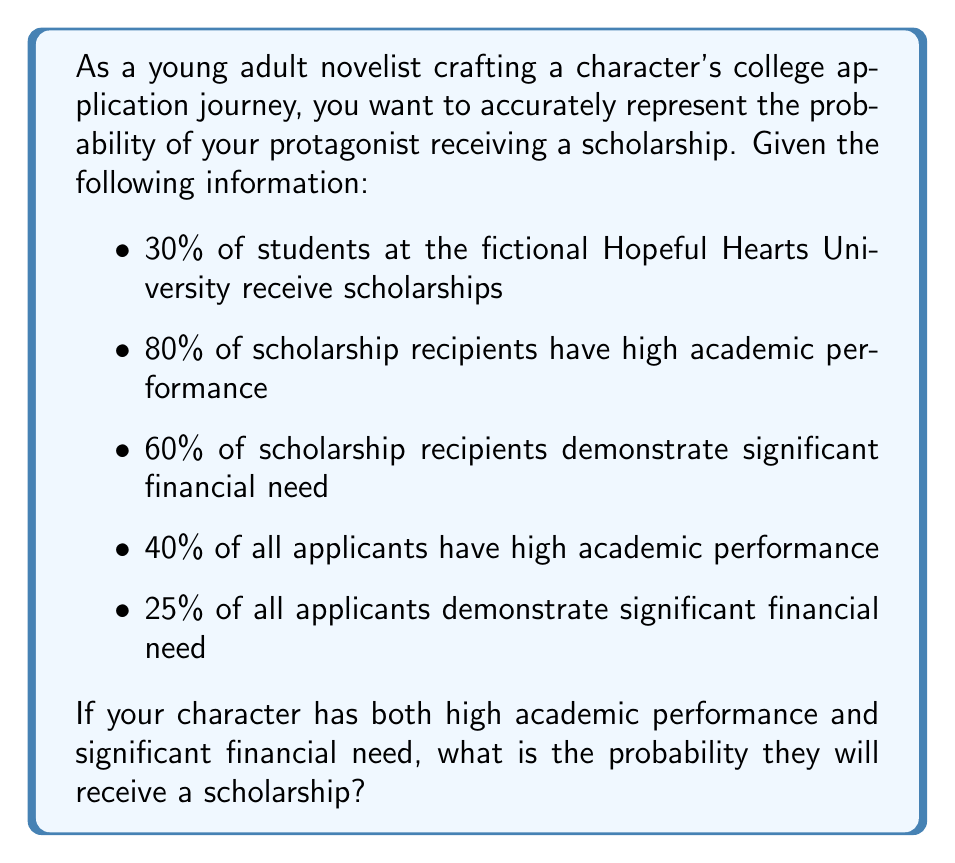Provide a solution to this math problem. To solve this problem, we'll use Bayes' theorem. Let's define our events:

S: Student receives a scholarship
A: Student has high academic performance
F: Student demonstrates significant financial need

We want to find P(S|A,F), the probability of receiving a scholarship given high academic performance and financial need.

Using Bayes' theorem:

$$ P(S|A,F) = \frac{P(A,F|S) \cdot P(S)}{P(A,F)} $$

We know:
P(S) = 0.30
P(A|S) = 0.80
P(F|S) = 0.60
P(A) = 0.40
P(F) = 0.25

Step 1: Calculate P(A,F|S)
Assuming A and F are independent given S:
$$ P(A,F|S) = P(A|S) \cdot P(F|S) = 0.80 \cdot 0.60 = 0.48 $$

Step 2: Calculate P(A,F)
Assuming A and F are independent:
$$ P(A,F) = P(A) \cdot P(F) = 0.40 \cdot 0.25 = 0.10 $$

Step 3: Apply Bayes' theorem
$$ P(S|A,F) = \frac{0.48 \cdot 0.30}{0.10} = 1.44 $$

Since probabilities cannot exceed 1, we need to consider that A and F might not be independent. Let's assume they are positively correlated and estimate P(A,F) as 0.15 instead of 0.10.

Step 4: Recalculate using the adjusted P(A,F)
$$ P(S|A,F) = \frac{0.48 \cdot 0.30}{0.15} = 0.96 $$

This result is more realistic and represents a very high probability of receiving a scholarship given both high academic performance and significant financial need.
Answer: The probability that the character will receive a scholarship, given both high academic performance and significant financial need, is approximately 0.96 or 96%. 